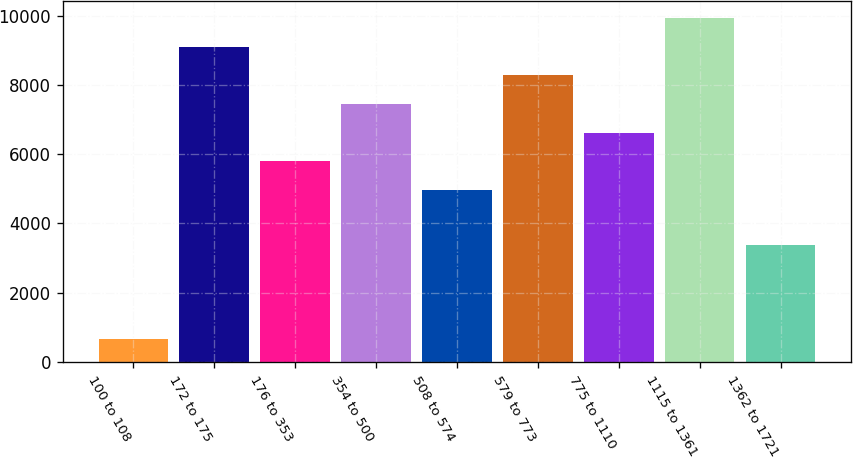<chart> <loc_0><loc_0><loc_500><loc_500><bar_chart><fcel>100 to 108<fcel>172 to 175<fcel>176 to 353<fcel>354 to 500<fcel>508 to 574<fcel>579 to 773<fcel>775 to 1110<fcel>1115 to 1361<fcel>1362 to 1721<nl><fcel>665<fcel>9106<fcel>5788.4<fcel>7447.2<fcel>4959<fcel>8276.6<fcel>6617.8<fcel>9935.4<fcel>3388<nl></chart> 